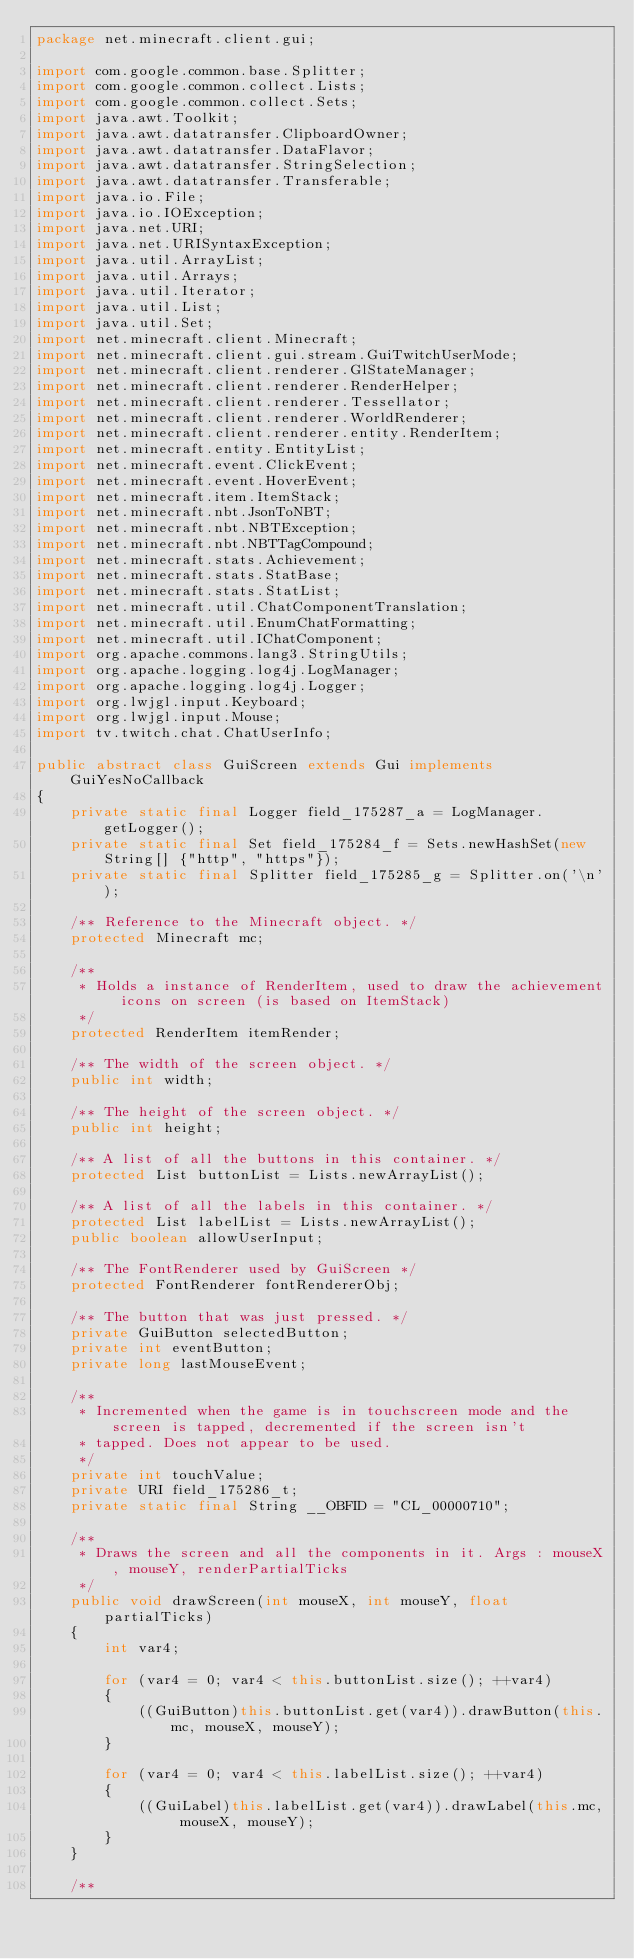Convert code to text. <code><loc_0><loc_0><loc_500><loc_500><_Java_>package net.minecraft.client.gui;

import com.google.common.base.Splitter;
import com.google.common.collect.Lists;
import com.google.common.collect.Sets;
import java.awt.Toolkit;
import java.awt.datatransfer.ClipboardOwner;
import java.awt.datatransfer.DataFlavor;
import java.awt.datatransfer.StringSelection;
import java.awt.datatransfer.Transferable;
import java.io.File;
import java.io.IOException;
import java.net.URI;
import java.net.URISyntaxException;
import java.util.ArrayList;
import java.util.Arrays;
import java.util.Iterator;
import java.util.List;
import java.util.Set;
import net.minecraft.client.Minecraft;
import net.minecraft.client.gui.stream.GuiTwitchUserMode;
import net.minecraft.client.renderer.GlStateManager;
import net.minecraft.client.renderer.RenderHelper;
import net.minecraft.client.renderer.Tessellator;
import net.minecraft.client.renderer.WorldRenderer;
import net.minecraft.client.renderer.entity.RenderItem;
import net.minecraft.entity.EntityList;
import net.minecraft.event.ClickEvent;
import net.minecraft.event.HoverEvent;
import net.minecraft.item.ItemStack;
import net.minecraft.nbt.JsonToNBT;
import net.minecraft.nbt.NBTException;
import net.minecraft.nbt.NBTTagCompound;
import net.minecraft.stats.Achievement;
import net.minecraft.stats.StatBase;
import net.minecraft.stats.StatList;
import net.minecraft.util.ChatComponentTranslation;
import net.minecraft.util.EnumChatFormatting;
import net.minecraft.util.IChatComponent;
import org.apache.commons.lang3.StringUtils;
import org.apache.logging.log4j.LogManager;
import org.apache.logging.log4j.Logger;
import org.lwjgl.input.Keyboard;
import org.lwjgl.input.Mouse;
import tv.twitch.chat.ChatUserInfo;

public abstract class GuiScreen extends Gui implements GuiYesNoCallback
{
    private static final Logger field_175287_a = LogManager.getLogger();
    private static final Set field_175284_f = Sets.newHashSet(new String[] {"http", "https"});
    private static final Splitter field_175285_g = Splitter.on('\n');

    /** Reference to the Minecraft object. */
    protected Minecraft mc;

    /**
     * Holds a instance of RenderItem, used to draw the achievement icons on screen (is based on ItemStack)
     */
    protected RenderItem itemRender;

    /** The width of the screen object. */
    public int width;

    /** The height of the screen object. */
    public int height;

    /** A list of all the buttons in this container. */
    protected List buttonList = Lists.newArrayList();

    /** A list of all the labels in this container. */
    protected List labelList = Lists.newArrayList();
    public boolean allowUserInput;

    /** The FontRenderer used by GuiScreen */
    protected FontRenderer fontRendererObj;

    /** The button that was just pressed. */
    private GuiButton selectedButton;
    private int eventButton;
    private long lastMouseEvent;

    /**
     * Incremented when the game is in touchscreen mode and the screen is tapped, decremented if the screen isn't
     * tapped. Does not appear to be used.
     */
    private int touchValue;
    private URI field_175286_t;
    private static final String __OBFID = "CL_00000710";

    /**
     * Draws the screen and all the components in it. Args : mouseX, mouseY, renderPartialTicks
     */
    public void drawScreen(int mouseX, int mouseY, float partialTicks)
    {
        int var4;

        for (var4 = 0; var4 < this.buttonList.size(); ++var4)
        {
            ((GuiButton)this.buttonList.get(var4)).drawButton(this.mc, mouseX, mouseY);
        }

        for (var4 = 0; var4 < this.labelList.size(); ++var4)
        {
            ((GuiLabel)this.labelList.get(var4)).drawLabel(this.mc, mouseX, mouseY);
        }
    }

    /**</code> 